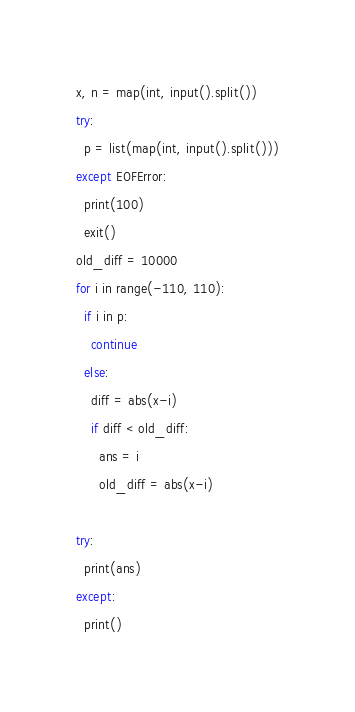Convert code to text. <code><loc_0><loc_0><loc_500><loc_500><_Python_>x, n = map(int, input().split())
try:
  p = list(map(int, input().split()))
except EOFError:
  print(100)
  exit()
old_diff = 10000
for i in range(-110, 110):
  if i in p:
    continue
  else:
    diff = abs(x-i)
    if diff < old_diff:
      ans = i
      old_diff = abs(x-i)

try:
  print(ans)
except:
  print()
</code> 